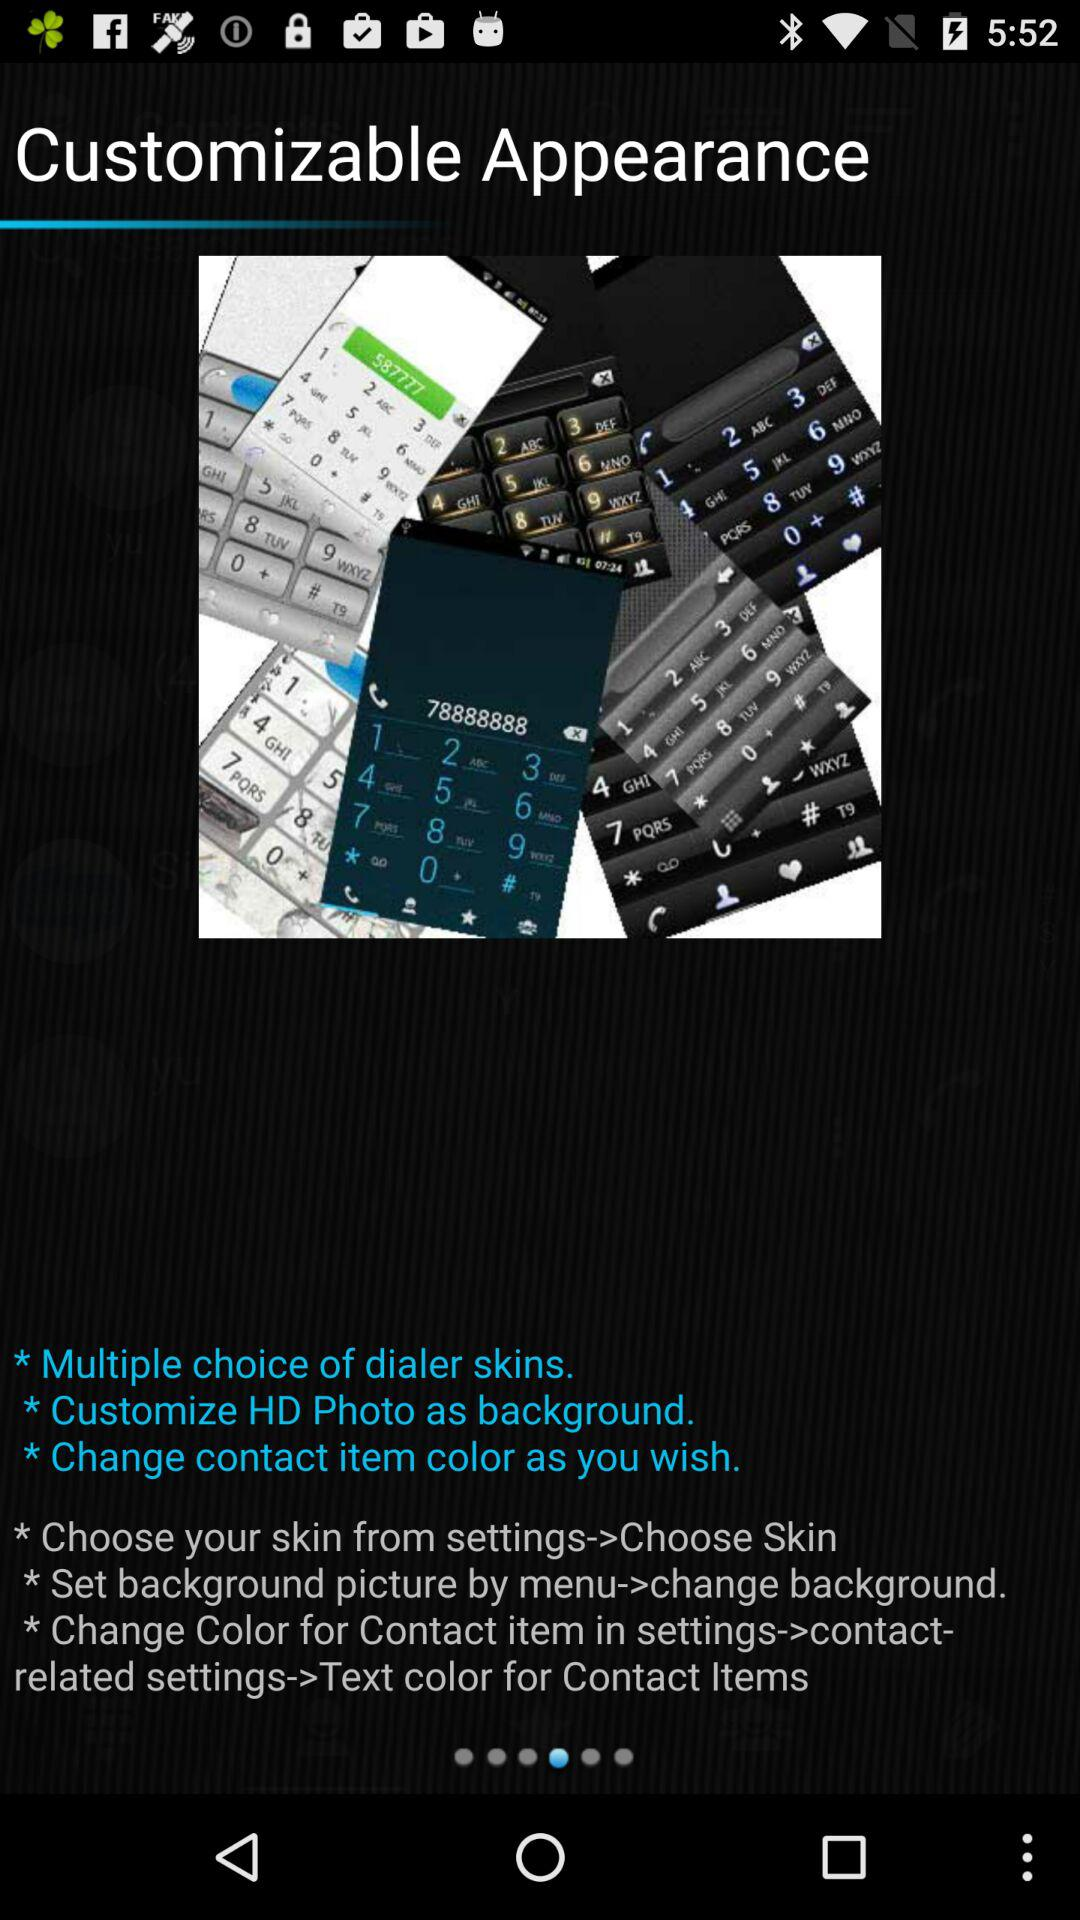How many text blocks describe how to change the appearance of the dialer?
Answer the question using a single word or phrase. 3 